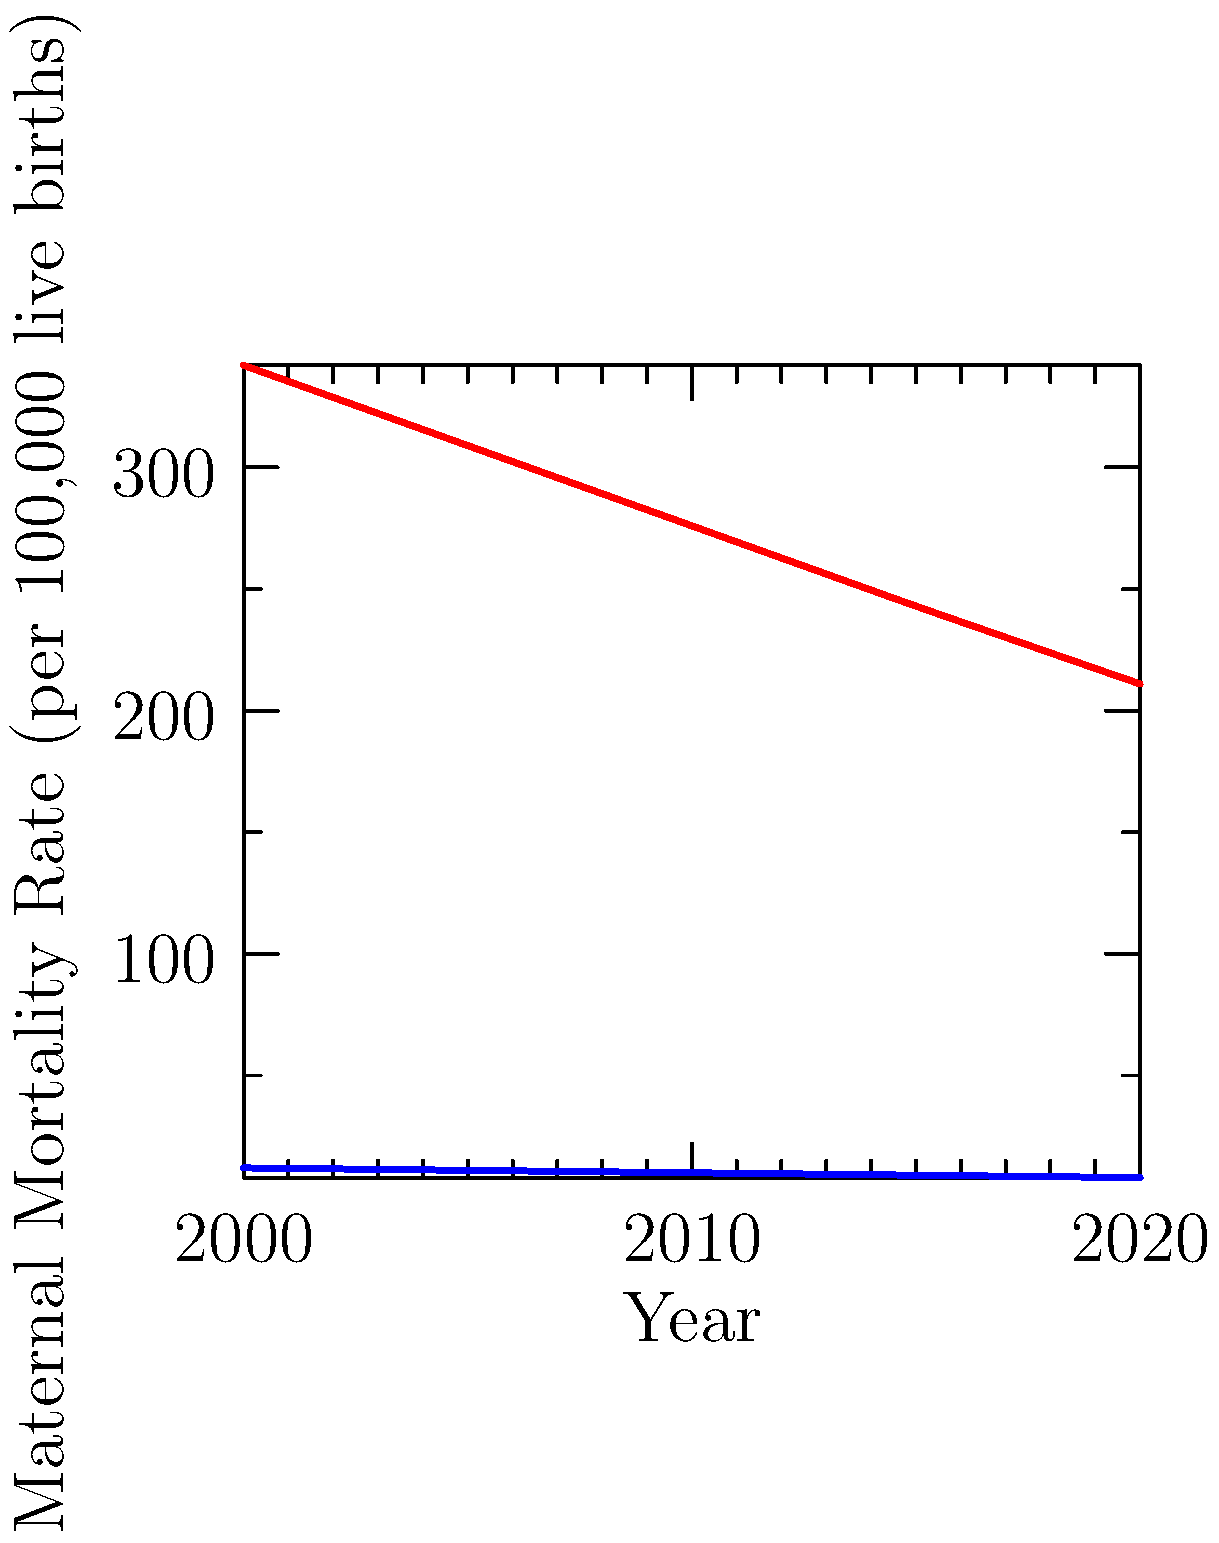Based on the graph comparing maternal mortality rates in developed and developing countries from 2000 to 2020, what conclusion can be drawn about the progress made in reducing maternal mortality in both types of countries? How might this information inform discussions on global health initiatives and women's rights? To answer this question, let's analyze the graph step-by-step:

1. Developed Countries:
   - In 2000: Approximately 12 deaths per 100,000 live births
   - In 2020: Approximately 8 deaths per 100,000 live births
   - Reduction: About 33% over 20 years

2. Developing Countries:
   - In 2000: Approximately 342 deaths per 100,000 live births
   - In 2020: Approximately 211 deaths per 100,000 live births
   - Reduction: About 38% over 20 years

3. Comparison of progress:
   - Both groups show a consistent downward trend
   - Developing countries have made slightly more progress in percentage terms (38% vs. 33%)
   - However, the absolute gap remains large (211 vs. 8 deaths per 100,000 live births in 2020)

4. Implications for global health initiatives:
   - Significant progress has been made in both developed and developing countries
   - The much higher rates in developing countries suggest a need for continued focus on these areas
   - The consistent downward trend indicates that current initiatives are having a positive impact

5. Relevance to women's rights discussions:
   - The stark difference in mortality rates highlights ongoing health inequalities between developed and developing nations
   - The data supports arguments for increased investment in maternal health care in developing countries
   - The progress made demonstrates that improvements are possible with proper focus and resources

Conclusion: While both developed and developing countries have made significant progress in reducing maternal mortality rates, a large disparity still exists. This data underscores the importance of continued global health initiatives focused on maternal care, particularly in developing nations, and supports arguments for increased attention to women's health as a fundamental right.
Answer: Both developed and developing countries have made significant progress in reducing maternal mortality rates, but a large disparity remains, highlighting the need for continued global health initiatives and support for women's rights, particularly in developing nations. 